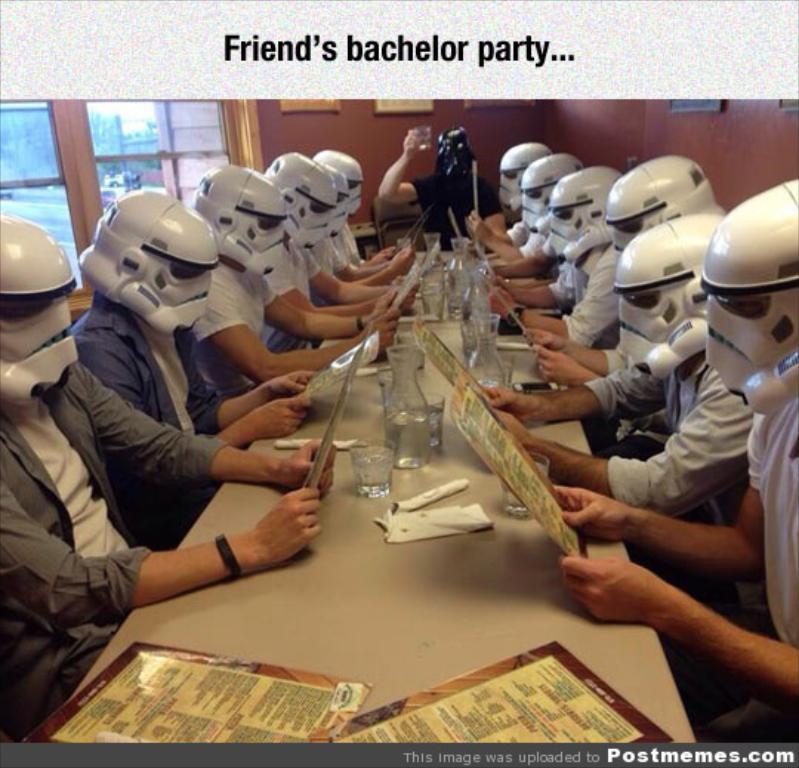Could you give a brief overview of what you see in this image? In this picture I can see number of people who are sitting and I see a table in front of them, on which there are glasses and few papers and I see that all of them are wearing helmets, which are of black and white in color and I see that few of them are holding papers. In the background I see the wall and on the left side of this image I see the windows. 